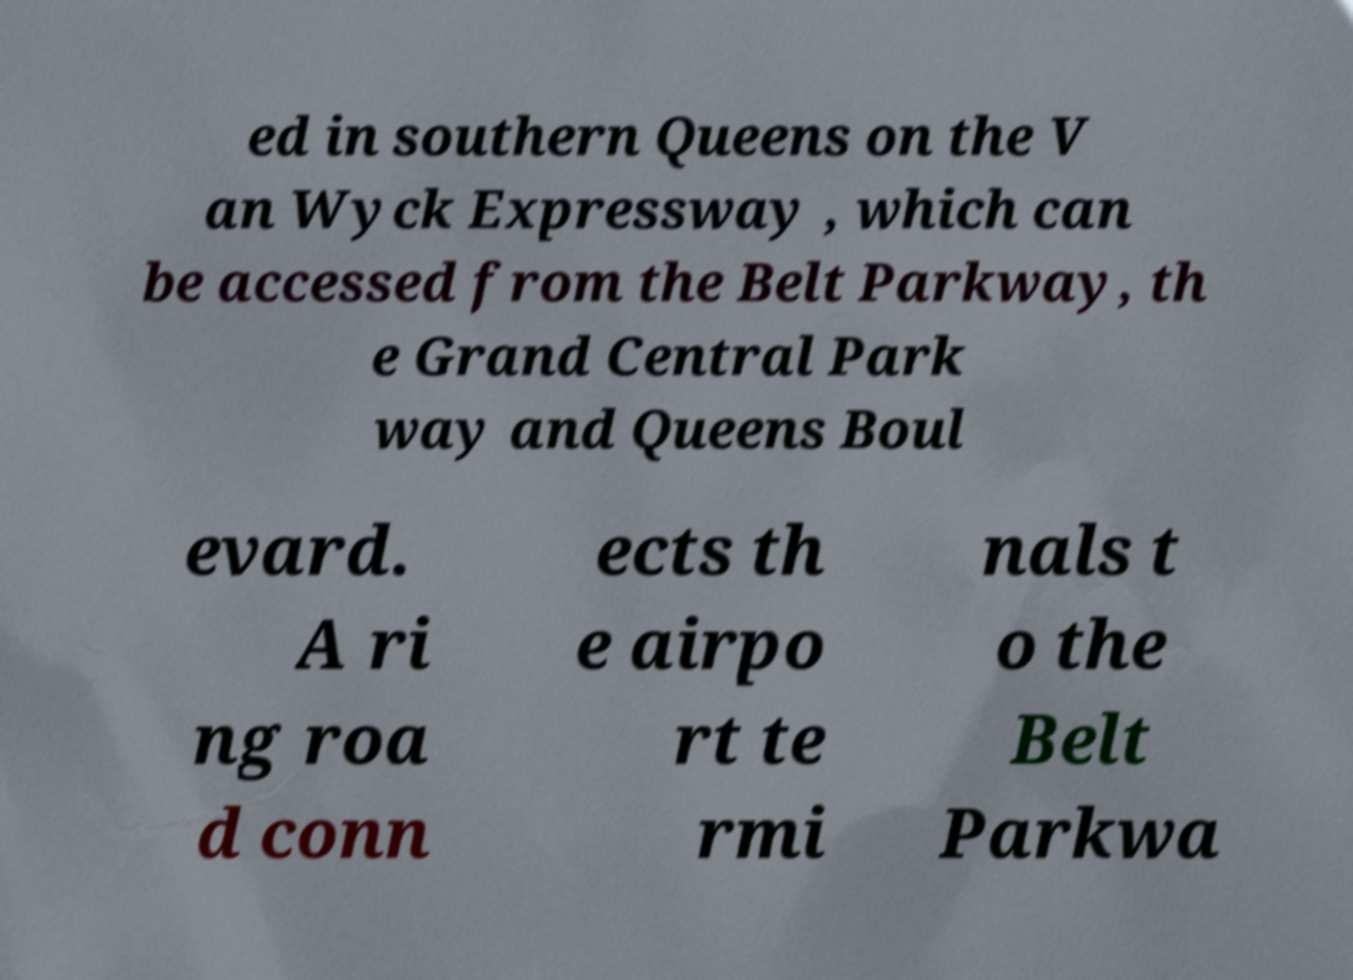There's text embedded in this image that I need extracted. Can you transcribe it verbatim? ed in southern Queens on the V an Wyck Expressway , which can be accessed from the Belt Parkway, th e Grand Central Park way and Queens Boul evard. A ri ng roa d conn ects th e airpo rt te rmi nals t o the Belt Parkwa 